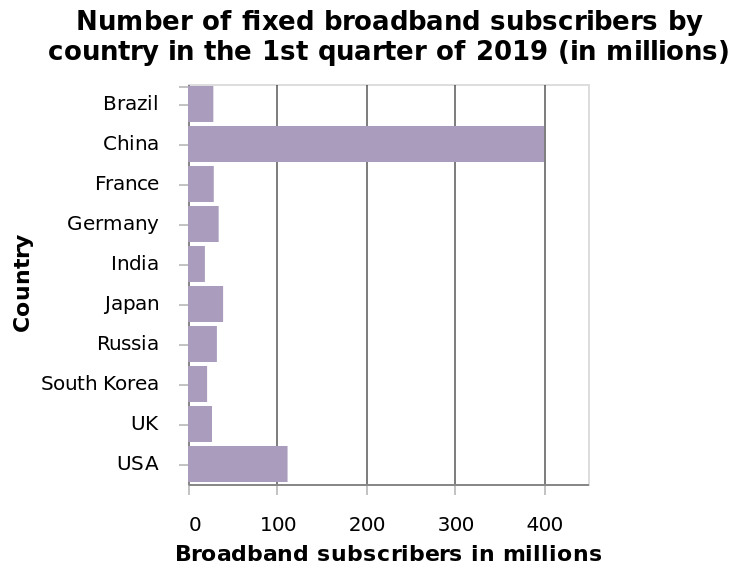<image>
Which country has the highest number of broadband subscribers?  China has the highest number of broadband subscribers. 